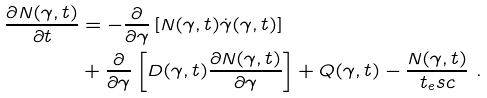<formula> <loc_0><loc_0><loc_500><loc_500>\frac { \partial N ( \gamma , t ) } { \partial t } & = - \frac { \partial } { \partial \gamma } \left [ N ( \gamma , t ) \dot { \gamma } ( \gamma , t ) \right ] \\ & + \frac { \partial } { \partial \gamma } \left [ D ( \gamma , t ) \frac { \partial N ( \gamma , t ) } { \partial \gamma } \right ] + Q ( \gamma , t ) - \frac { N ( \gamma , t ) } { t _ { e } s c } \ .</formula> 